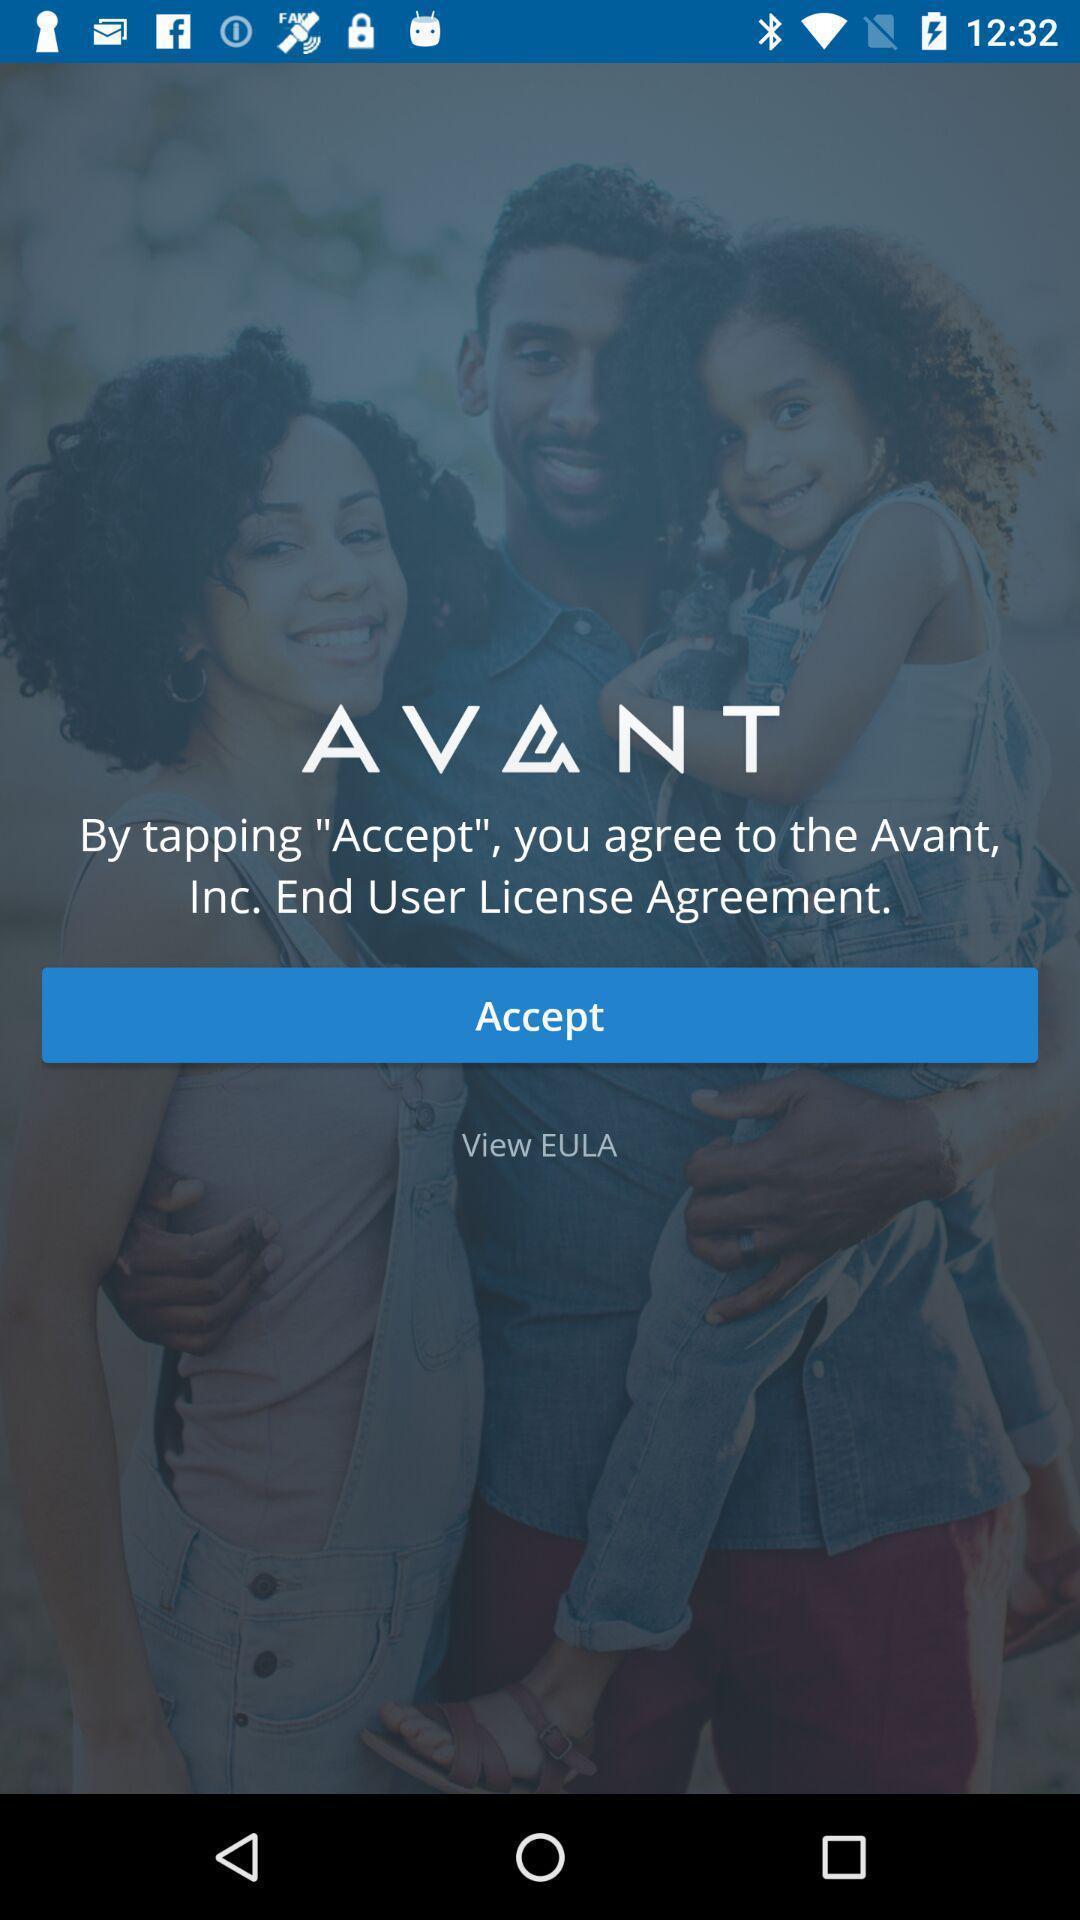Give me a summary of this screen capture. Page displaying to accept the user agreement. 